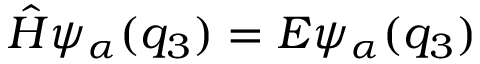Convert formula to latex. <formula><loc_0><loc_0><loc_500><loc_500>\hat { H } \psi _ { \alpha } ( q _ { 3 } ) = E \psi _ { \alpha } ( q _ { 3 } )</formula> 